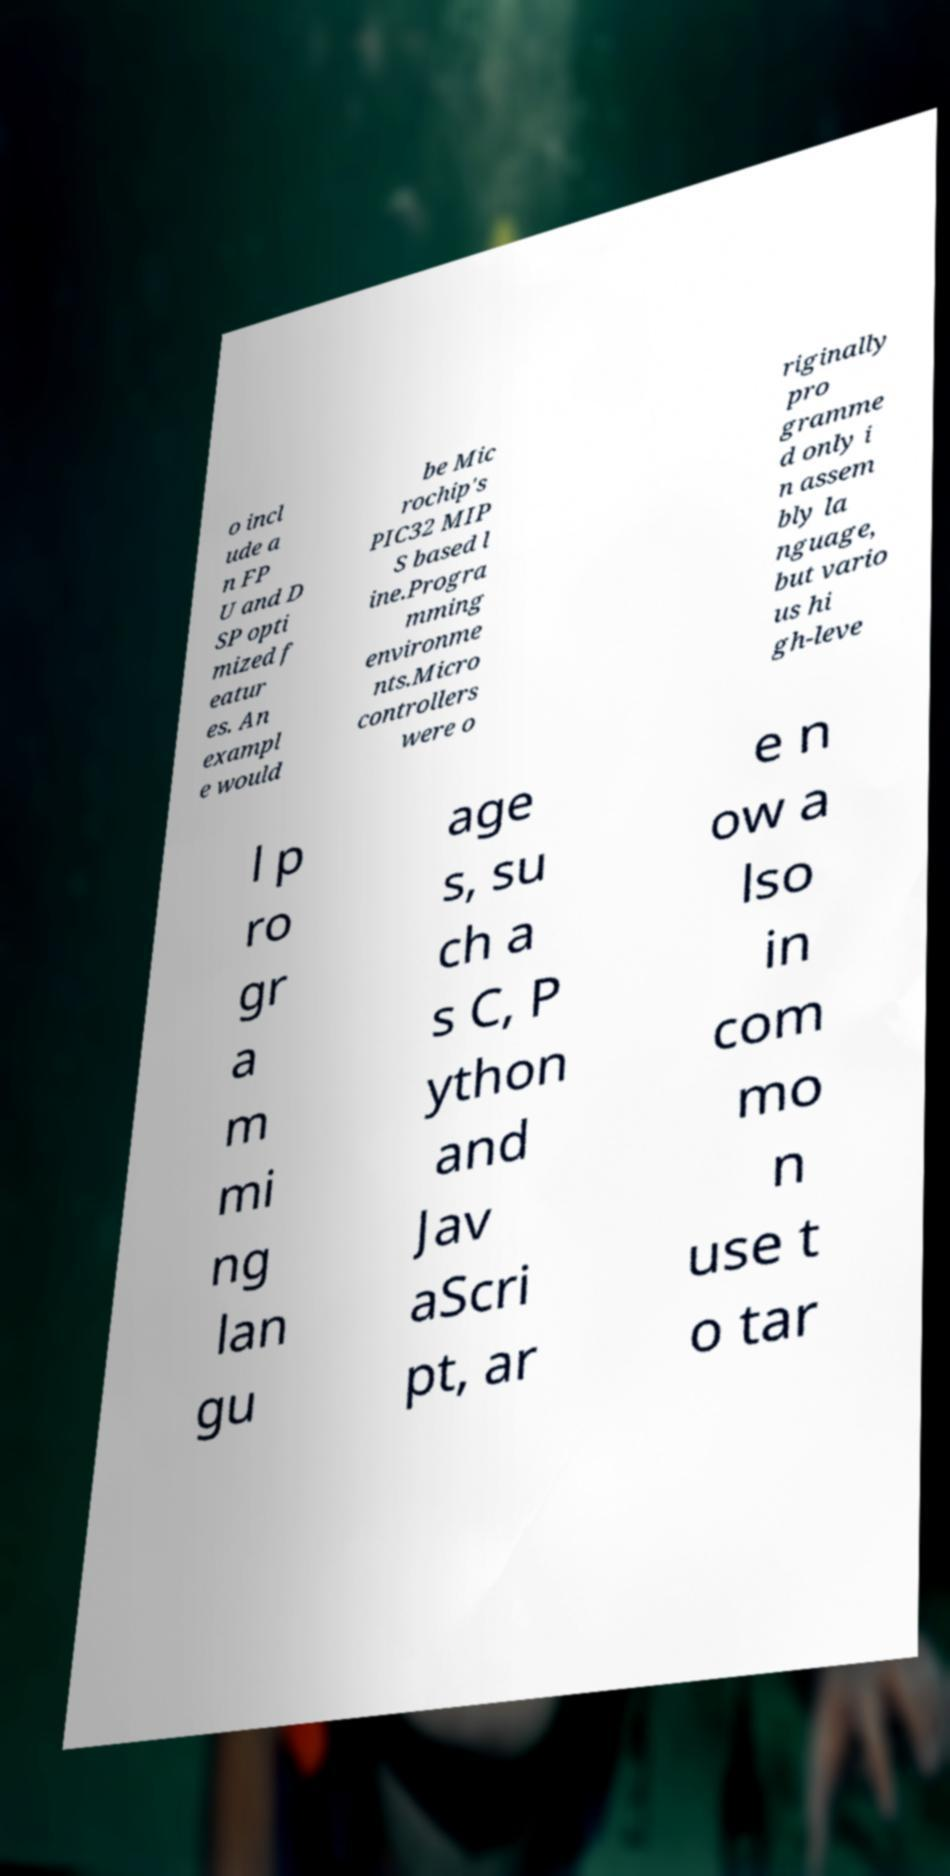For documentation purposes, I need the text within this image transcribed. Could you provide that? o incl ude a n FP U and D SP opti mized f eatur es. An exampl e would be Mic rochip's PIC32 MIP S based l ine.Progra mming environme nts.Micro controllers were o riginally pro gramme d only i n assem bly la nguage, but vario us hi gh-leve l p ro gr a m mi ng lan gu age s, su ch a s C, P ython and Jav aScri pt, ar e n ow a lso in com mo n use t o tar 